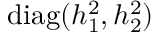Convert formula to latex. <formula><loc_0><loc_0><loc_500><loc_500>d i a g ( h _ { 1 } ^ { 2 } , h _ { 2 } ^ { 2 } )</formula> 